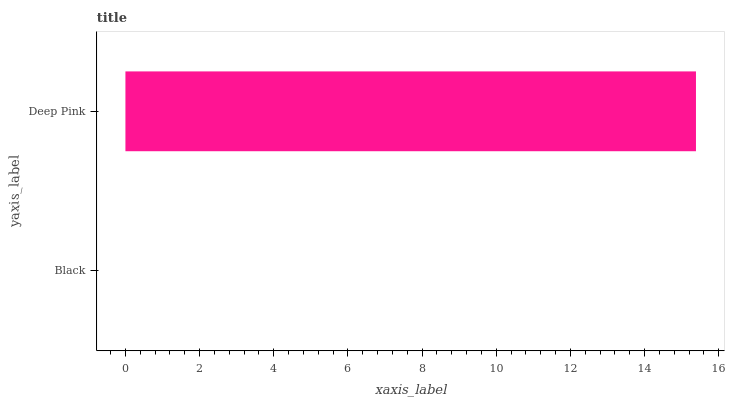Is Black the minimum?
Answer yes or no. Yes. Is Deep Pink the maximum?
Answer yes or no. Yes. Is Deep Pink the minimum?
Answer yes or no. No. Is Deep Pink greater than Black?
Answer yes or no. Yes. Is Black less than Deep Pink?
Answer yes or no. Yes. Is Black greater than Deep Pink?
Answer yes or no. No. Is Deep Pink less than Black?
Answer yes or no. No. Is Deep Pink the high median?
Answer yes or no. Yes. Is Black the low median?
Answer yes or no. Yes. Is Black the high median?
Answer yes or no. No. Is Deep Pink the low median?
Answer yes or no. No. 